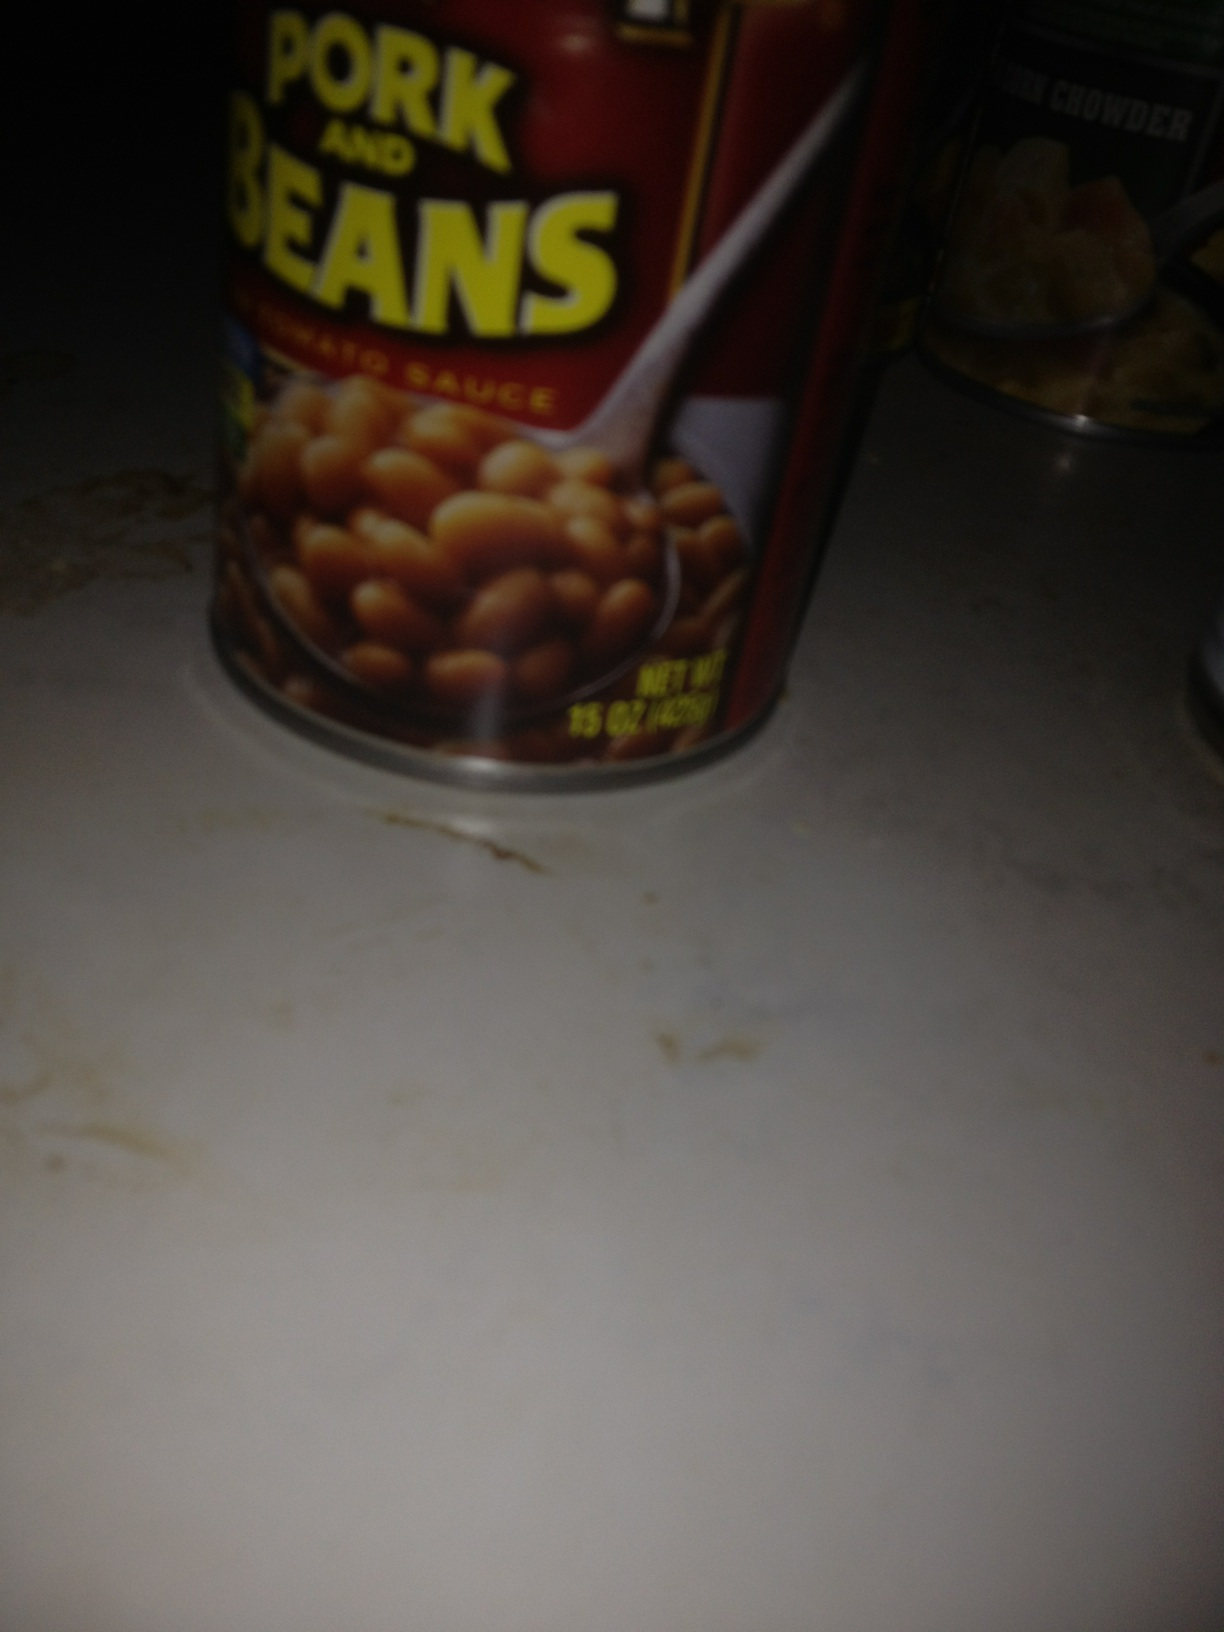What do you think these cans dream about when they’re sitting on the shelf? The Pork and Beans can likely dreams of being chosen for a cozy family dinner, where it will be the star of a classic dish everyone loves. It imagines being heated up on a stove and served alongside grilled hot dogs or a barbecue feast, bringing smiles and satisfaction to all. The New England Clam Chowder can, on the other hand, dreams of a cold winter evening, when someone reaches for it to create a warm, hearty soup that fills the room with an inviting aroma. Both cans dream of fulfilling their delicious destinies and providing comfort and joy to those who consume them. 